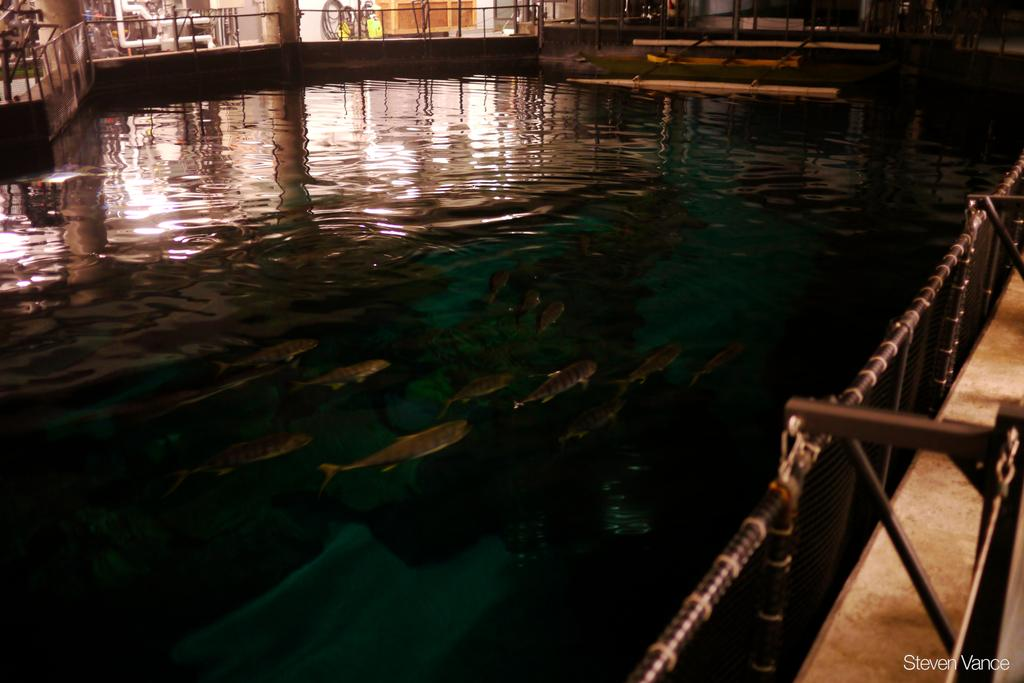What type of material is used to construct the objects in the image? The metal rods in the image are made of metal. What structure can be seen in the image? There is a fence in the image. What type of animals are present in the image? There are fishes in the water in the image. How many yaks are visible in the image? There are no yaks present in the image. What type of trade is being conducted in the image? There is no trade being conducted in the image. 